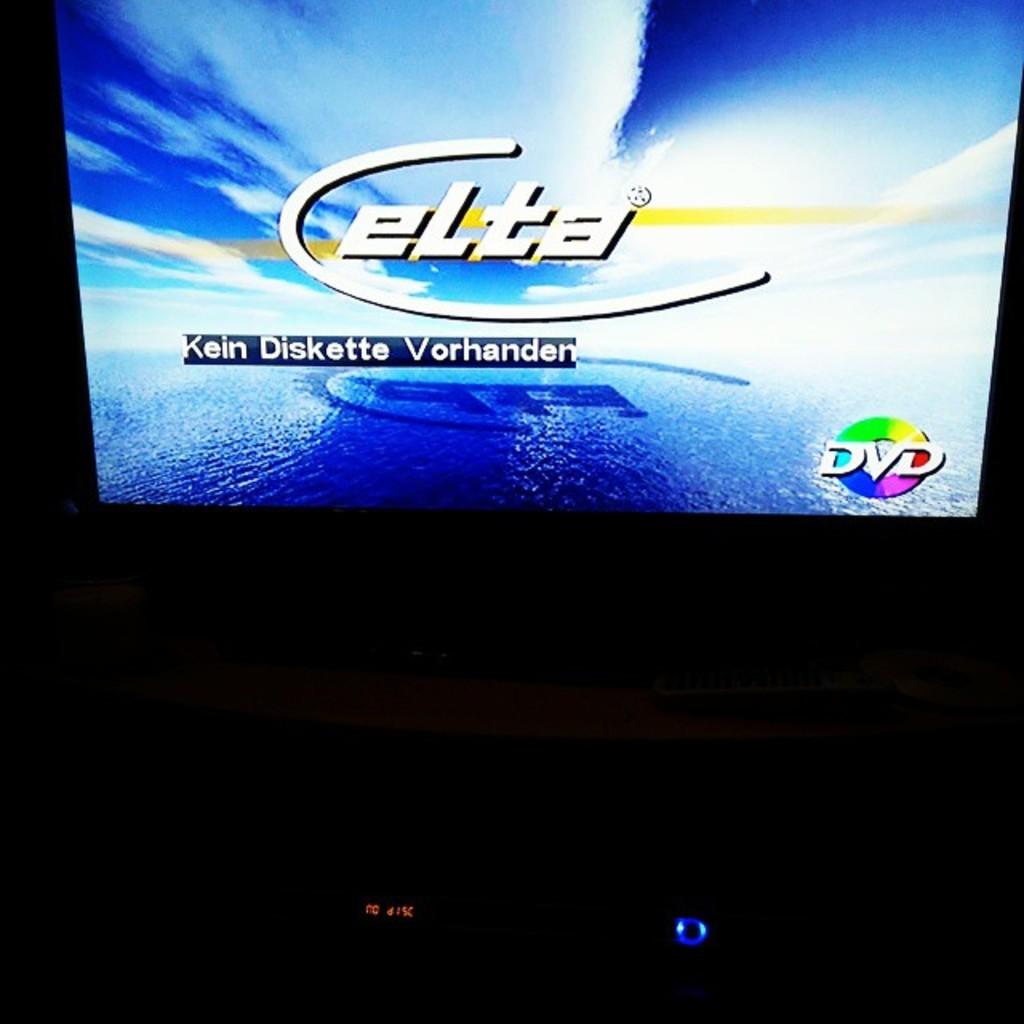What are they watching?
Ensure brevity in your answer.  Elta. What is the movie title?
Offer a terse response. Elta. 